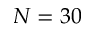<formula> <loc_0><loc_0><loc_500><loc_500>N = 3 0</formula> 